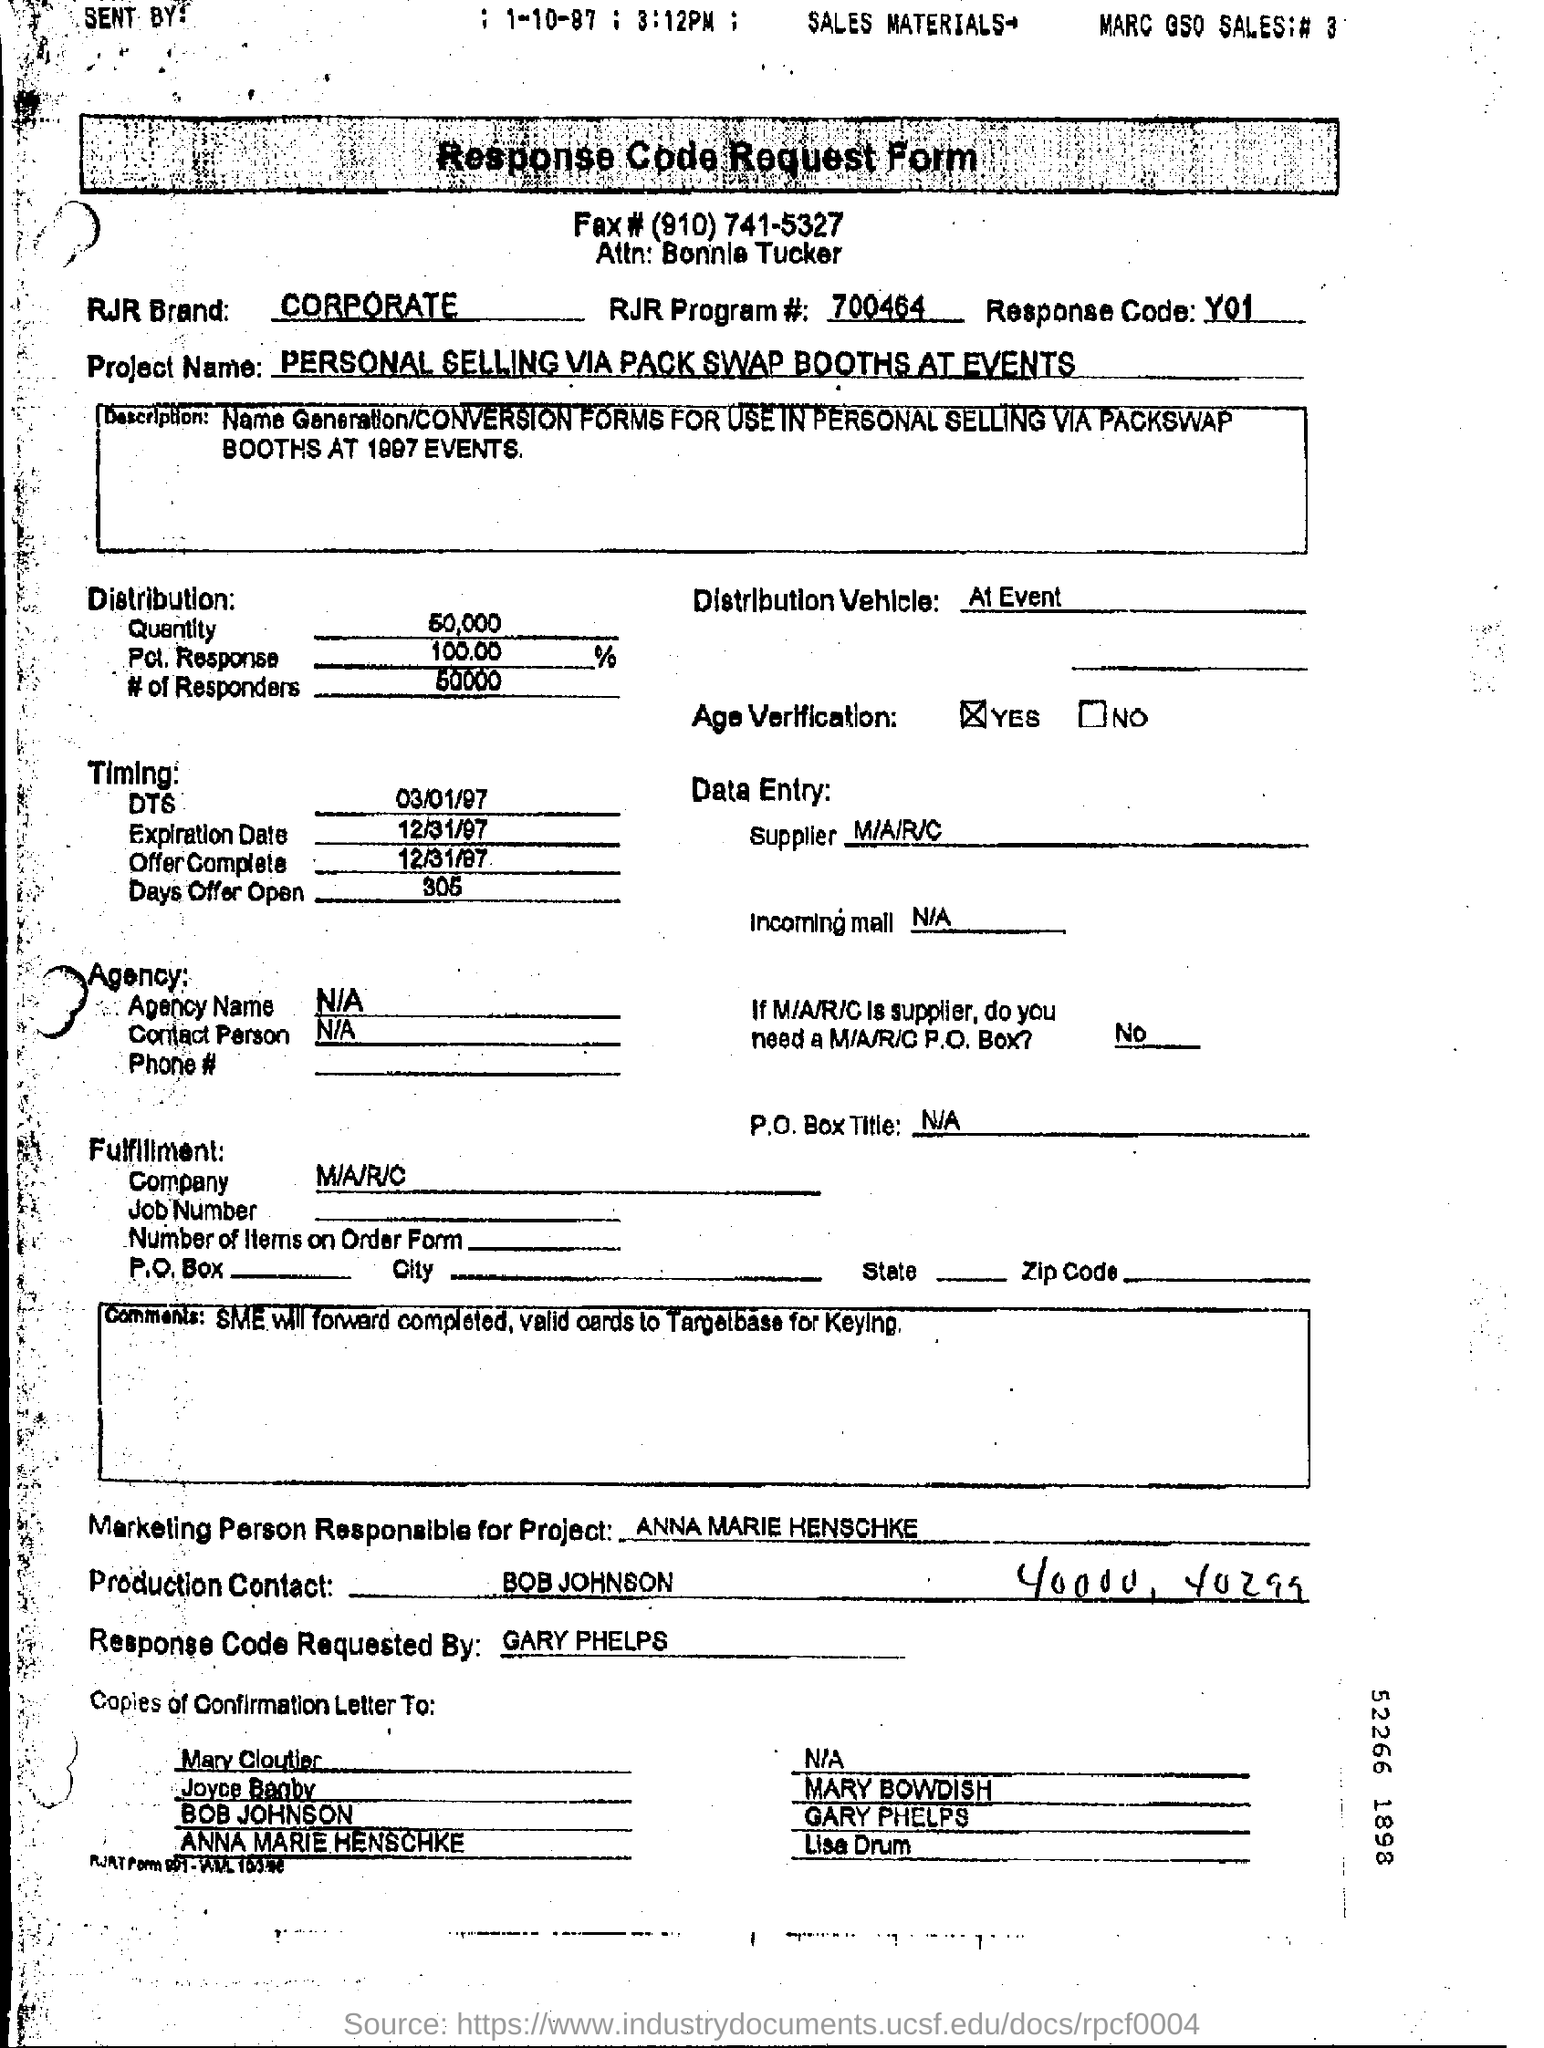Indicate a few pertinent items in this graphic. The production contact is Bob Johnson. The marketing person responsible for the project is Anna Marie Henschke. The project name is "Personal Selling via Pack Swap Booths at Events," which aims to utilize pack swap booths at events to promote personal selling and foster a sense of community among attendees. 